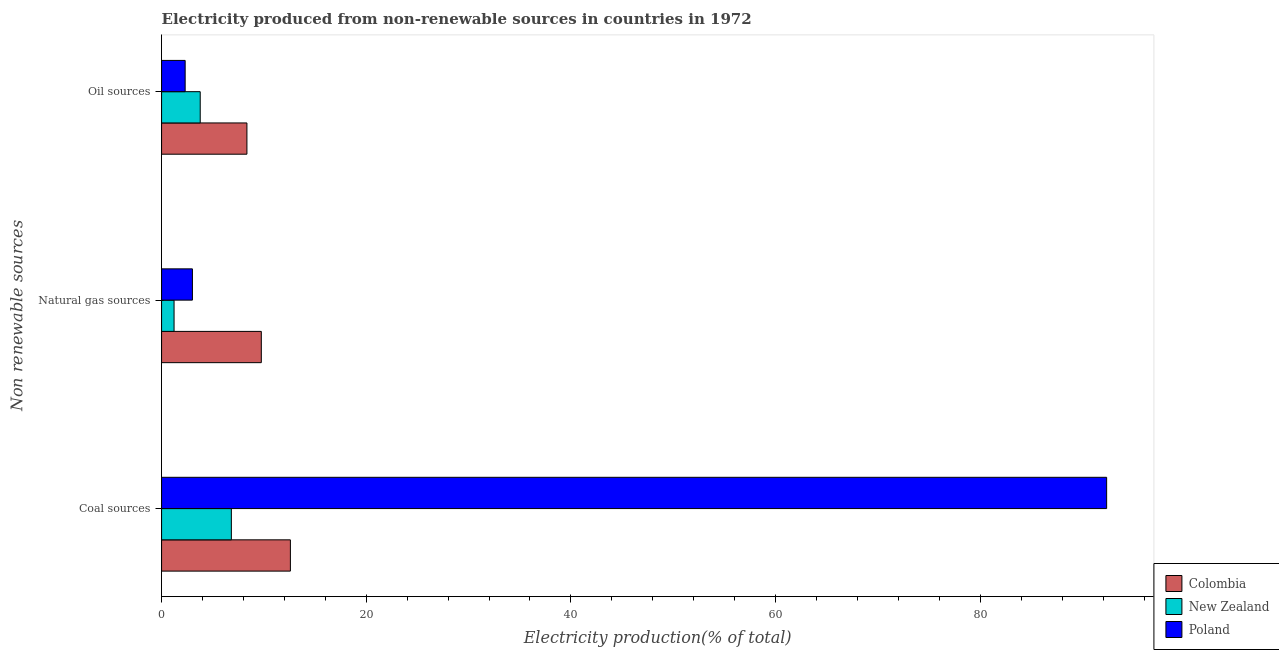How many different coloured bars are there?
Make the answer very short. 3. How many bars are there on the 1st tick from the top?
Make the answer very short. 3. How many bars are there on the 1st tick from the bottom?
Provide a succinct answer. 3. What is the label of the 2nd group of bars from the top?
Offer a terse response. Natural gas sources. What is the percentage of electricity produced by oil sources in Poland?
Offer a very short reply. 2.3. Across all countries, what is the maximum percentage of electricity produced by oil sources?
Make the answer very short. 8.34. Across all countries, what is the minimum percentage of electricity produced by coal?
Your response must be concise. 6.82. In which country was the percentage of electricity produced by oil sources minimum?
Your answer should be compact. Poland. What is the total percentage of electricity produced by oil sources in the graph?
Give a very brief answer. 14.42. What is the difference between the percentage of electricity produced by oil sources in New Zealand and that in Poland?
Ensure brevity in your answer.  1.47. What is the difference between the percentage of electricity produced by oil sources in Poland and the percentage of electricity produced by natural gas in Colombia?
Your response must be concise. -7.44. What is the average percentage of electricity produced by natural gas per country?
Provide a succinct answer. 4.66. What is the difference between the percentage of electricity produced by coal and percentage of electricity produced by natural gas in New Zealand?
Keep it short and to the point. 5.6. In how many countries, is the percentage of electricity produced by natural gas greater than 48 %?
Provide a succinct answer. 0. What is the ratio of the percentage of electricity produced by coal in Poland to that in Colombia?
Your answer should be very brief. 7.34. Is the percentage of electricity produced by oil sources in New Zealand less than that in Poland?
Ensure brevity in your answer.  No. What is the difference between the highest and the second highest percentage of electricity produced by coal?
Provide a short and direct response. 79.76. What is the difference between the highest and the lowest percentage of electricity produced by coal?
Make the answer very short. 85.53. In how many countries, is the percentage of electricity produced by oil sources greater than the average percentage of electricity produced by oil sources taken over all countries?
Your answer should be compact. 1. Is the sum of the percentage of electricity produced by coal in Colombia and Poland greater than the maximum percentage of electricity produced by natural gas across all countries?
Your answer should be very brief. Yes. What does the 3rd bar from the bottom in Coal sources represents?
Offer a very short reply. Poland. Is it the case that in every country, the sum of the percentage of electricity produced by coal and percentage of electricity produced by natural gas is greater than the percentage of electricity produced by oil sources?
Your answer should be compact. Yes. Does the graph contain grids?
Make the answer very short. No. Where does the legend appear in the graph?
Your response must be concise. Bottom right. How are the legend labels stacked?
Give a very brief answer. Vertical. What is the title of the graph?
Provide a short and direct response. Electricity produced from non-renewable sources in countries in 1972. What is the label or title of the X-axis?
Your answer should be compact. Electricity production(% of total). What is the label or title of the Y-axis?
Provide a short and direct response. Non renewable sources. What is the Electricity production(% of total) in Colombia in Coal sources?
Your answer should be compact. 12.59. What is the Electricity production(% of total) in New Zealand in Coal sources?
Offer a terse response. 6.82. What is the Electricity production(% of total) of Poland in Coal sources?
Make the answer very short. 92.35. What is the Electricity production(% of total) in Colombia in Natural gas sources?
Provide a short and direct response. 9.75. What is the Electricity production(% of total) in New Zealand in Natural gas sources?
Provide a short and direct response. 1.22. What is the Electricity production(% of total) in Poland in Natural gas sources?
Make the answer very short. 3.01. What is the Electricity production(% of total) in Colombia in Oil sources?
Offer a terse response. 8.34. What is the Electricity production(% of total) of New Zealand in Oil sources?
Ensure brevity in your answer.  3.78. What is the Electricity production(% of total) of Poland in Oil sources?
Provide a short and direct response. 2.3. Across all Non renewable sources, what is the maximum Electricity production(% of total) in Colombia?
Offer a terse response. 12.59. Across all Non renewable sources, what is the maximum Electricity production(% of total) in New Zealand?
Ensure brevity in your answer.  6.82. Across all Non renewable sources, what is the maximum Electricity production(% of total) in Poland?
Offer a terse response. 92.35. Across all Non renewable sources, what is the minimum Electricity production(% of total) of Colombia?
Make the answer very short. 8.34. Across all Non renewable sources, what is the minimum Electricity production(% of total) in New Zealand?
Your answer should be compact. 1.22. Across all Non renewable sources, what is the minimum Electricity production(% of total) in Poland?
Your answer should be compact. 2.3. What is the total Electricity production(% of total) in Colombia in the graph?
Give a very brief answer. 30.67. What is the total Electricity production(% of total) of New Zealand in the graph?
Ensure brevity in your answer.  11.82. What is the total Electricity production(% of total) in Poland in the graph?
Provide a short and direct response. 97.67. What is the difference between the Electricity production(% of total) in Colombia in Coal sources and that in Natural gas sources?
Your answer should be very brief. 2.84. What is the difference between the Electricity production(% of total) of New Zealand in Coal sources and that in Natural gas sources?
Make the answer very short. 5.6. What is the difference between the Electricity production(% of total) in Poland in Coal sources and that in Natural gas sources?
Give a very brief answer. 89.33. What is the difference between the Electricity production(% of total) in Colombia in Coal sources and that in Oil sources?
Ensure brevity in your answer.  4.25. What is the difference between the Electricity production(% of total) in New Zealand in Coal sources and that in Oil sources?
Provide a short and direct response. 3.04. What is the difference between the Electricity production(% of total) of Poland in Coal sources and that in Oil sources?
Ensure brevity in your answer.  90.04. What is the difference between the Electricity production(% of total) of Colombia in Natural gas sources and that in Oil sources?
Your response must be concise. 1.41. What is the difference between the Electricity production(% of total) in New Zealand in Natural gas sources and that in Oil sources?
Make the answer very short. -2.55. What is the difference between the Electricity production(% of total) of Poland in Natural gas sources and that in Oil sources?
Keep it short and to the point. 0.71. What is the difference between the Electricity production(% of total) of Colombia in Coal sources and the Electricity production(% of total) of New Zealand in Natural gas sources?
Keep it short and to the point. 11.37. What is the difference between the Electricity production(% of total) of Colombia in Coal sources and the Electricity production(% of total) of Poland in Natural gas sources?
Make the answer very short. 9.57. What is the difference between the Electricity production(% of total) of New Zealand in Coal sources and the Electricity production(% of total) of Poland in Natural gas sources?
Ensure brevity in your answer.  3.8. What is the difference between the Electricity production(% of total) of Colombia in Coal sources and the Electricity production(% of total) of New Zealand in Oil sources?
Provide a short and direct response. 8.81. What is the difference between the Electricity production(% of total) in Colombia in Coal sources and the Electricity production(% of total) in Poland in Oil sources?
Offer a terse response. 10.28. What is the difference between the Electricity production(% of total) of New Zealand in Coal sources and the Electricity production(% of total) of Poland in Oil sources?
Give a very brief answer. 4.51. What is the difference between the Electricity production(% of total) in Colombia in Natural gas sources and the Electricity production(% of total) in New Zealand in Oil sources?
Ensure brevity in your answer.  5.97. What is the difference between the Electricity production(% of total) in Colombia in Natural gas sources and the Electricity production(% of total) in Poland in Oil sources?
Offer a very short reply. 7.44. What is the difference between the Electricity production(% of total) of New Zealand in Natural gas sources and the Electricity production(% of total) of Poland in Oil sources?
Provide a succinct answer. -1.08. What is the average Electricity production(% of total) of Colombia per Non renewable sources?
Ensure brevity in your answer.  10.22. What is the average Electricity production(% of total) of New Zealand per Non renewable sources?
Your answer should be compact. 3.94. What is the average Electricity production(% of total) in Poland per Non renewable sources?
Offer a very short reply. 32.56. What is the difference between the Electricity production(% of total) of Colombia and Electricity production(% of total) of New Zealand in Coal sources?
Your answer should be compact. 5.77. What is the difference between the Electricity production(% of total) in Colombia and Electricity production(% of total) in Poland in Coal sources?
Your answer should be very brief. -79.76. What is the difference between the Electricity production(% of total) in New Zealand and Electricity production(% of total) in Poland in Coal sources?
Ensure brevity in your answer.  -85.53. What is the difference between the Electricity production(% of total) in Colombia and Electricity production(% of total) in New Zealand in Natural gas sources?
Keep it short and to the point. 8.53. What is the difference between the Electricity production(% of total) in Colombia and Electricity production(% of total) in Poland in Natural gas sources?
Provide a short and direct response. 6.73. What is the difference between the Electricity production(% of total) of New Zealand and Electricity production(% of total) of Poland in Natural gas sources?
Provide a short and direct response. -1.79. What is the difference between the Electricity production(% of total) in Colombia and Electricity production(% of total) in New Zealand in Oil sources?
Make the answer very short. 4.56. What is the difference between the Electricity production(% of total) of Colombia and Electricity production(% of total) of Poland in Oil sources?
Your response must be concise. 6.04. What is the difference between the Electricity production(% of total) in New Zealand and Electricity production(% of total) in Poland in Oil sources?
Provide a short and direct response. 1.47. What is the ratio of the Electricity production(% of total) of Colombia in Coal sources to that in Natural gas sources?
Offer a terse response. 1.29. What is the ratio of the Electricity production(% of total) in New Zealand in Coal sources to that in Natural gas sources?
Ensure brevity in your answer.  5.59. What is the ratio of the Electricity production(% of total) in Poland in Coal sources to that in Natural gas sources?
Offer a terse response. 30.64. What is the ratio of the Electricity production(% of total) in Colombia in Coal sources to that in Oil sources?
Provide a short and direct response. 1.51. What is the ratio of the Electricity production(% of total) in New Zealand in Coal sources to that in Oil sources?
Ensure brevity in your answer.  1.81. What is the ratio of the Electricity production(% of total) in Poland in Coal sources to that in Oil sources?
Offer a terse response. 40.08. What is the ratio of the Electricity production(% of total) of Colombia in Natural gas sources to that in Oil sources?
Offer a very short reply. 1.17. What is the ratio of the Electricity production(% of total) in New Zealand in Natural gas sources to that in Oil sources?
Your response must be concise. 0.32. What is the ratio of the Electricity production(% of total) in Poland in Natural gas sources to that in Oil sources?
Your answer should be compact. 1.31. What is the difference between the highest and the second highest Electricity production(% of total) of Colombia?
Your answer should be compact. 2.84. What is the difference between the highest and the second highest Electricity production(% of total) of New Zealand?
Your answer should be compact. 3.04. What is the difference between the highest and the second highest Electricity production(% of total) in Poland?
Your response must be concise. 89.33. What is the difference between the highest and the lowest Electricity production(% of total) in Colombia?
Offer a terse response. 4.25. What is the difference between the highest and the lowest Electricity production(% of total) of New Zealand?
Your answer should be very brief. 5.6. What is the difference between the highest and the lowest Electricity production(% of total) of Poland?
Give a very brief answer. 90.04. 